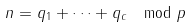<formula> <loc_0><loc_0><loc_500><loc_500>n = q _ { 1 } + \cdots + q _ { c } \mod p</formula> 